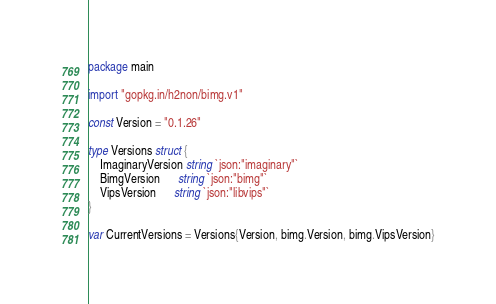<code> <loc_0><loc_0><loc_500><loc_500><_Go_>package main

import "gopkg.in/h2non/bimg.v1"

const Version = "0.1.26"

type Versions struct {
	ImaginaryVersion string `json:"imaginary"`
	BimgVersion      string `json:"bimg"`
	VipsVersion      string `json:"libvips"`
}

var CurrentVersions = Versions{Version, bimg.Version, bimg.VipsVersion}
</code> 